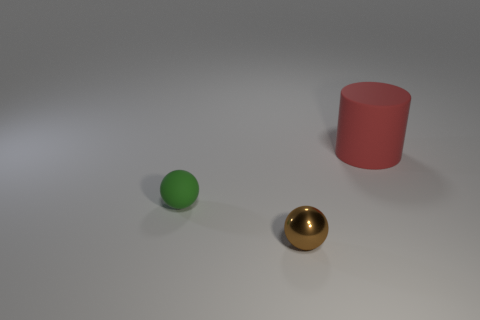There is a thing that is behind the tiny object that is behind the metallic ball; how big is it?
Offer a very short reply. Large. What color is the thing that is right of the green sphere and behind the shiny sphere?
Your answer should be compact. Red. Is the shape of the brown object the same as the red matte thing?
Keep it short and to the point. No. Are there an equal number of big red objects and tiny blue matte cubes?
Your answer should be very brief. No. There is a matte thing behind the rubber object that is on the left side of the large red rubber cylinder; what is its shape?
Ensure brevity in your answer.  Cylinder. Is the shape of the shiny object the same as the rubber thing left of the red cylinder?
Give a very brief answer. Yes. The object that is the same size as the brown ball is what color?
Ensure brevity in your answer.  Green. Is the number of matte cylinders in front of the small matte thing less than the number of brown metallic balls right of the brown sphere?
Offer a terse response. No. There is a rubber thing that is left of the red matte cylinder behind the matte thing that is left of the tiny shiny sphere; what is its shape?
Offer a very short reply. Sphere. Is the color of the matte object in front of the large cylinder the same as the matte object behind the small green matte ball?
Make the answer very short. No. 